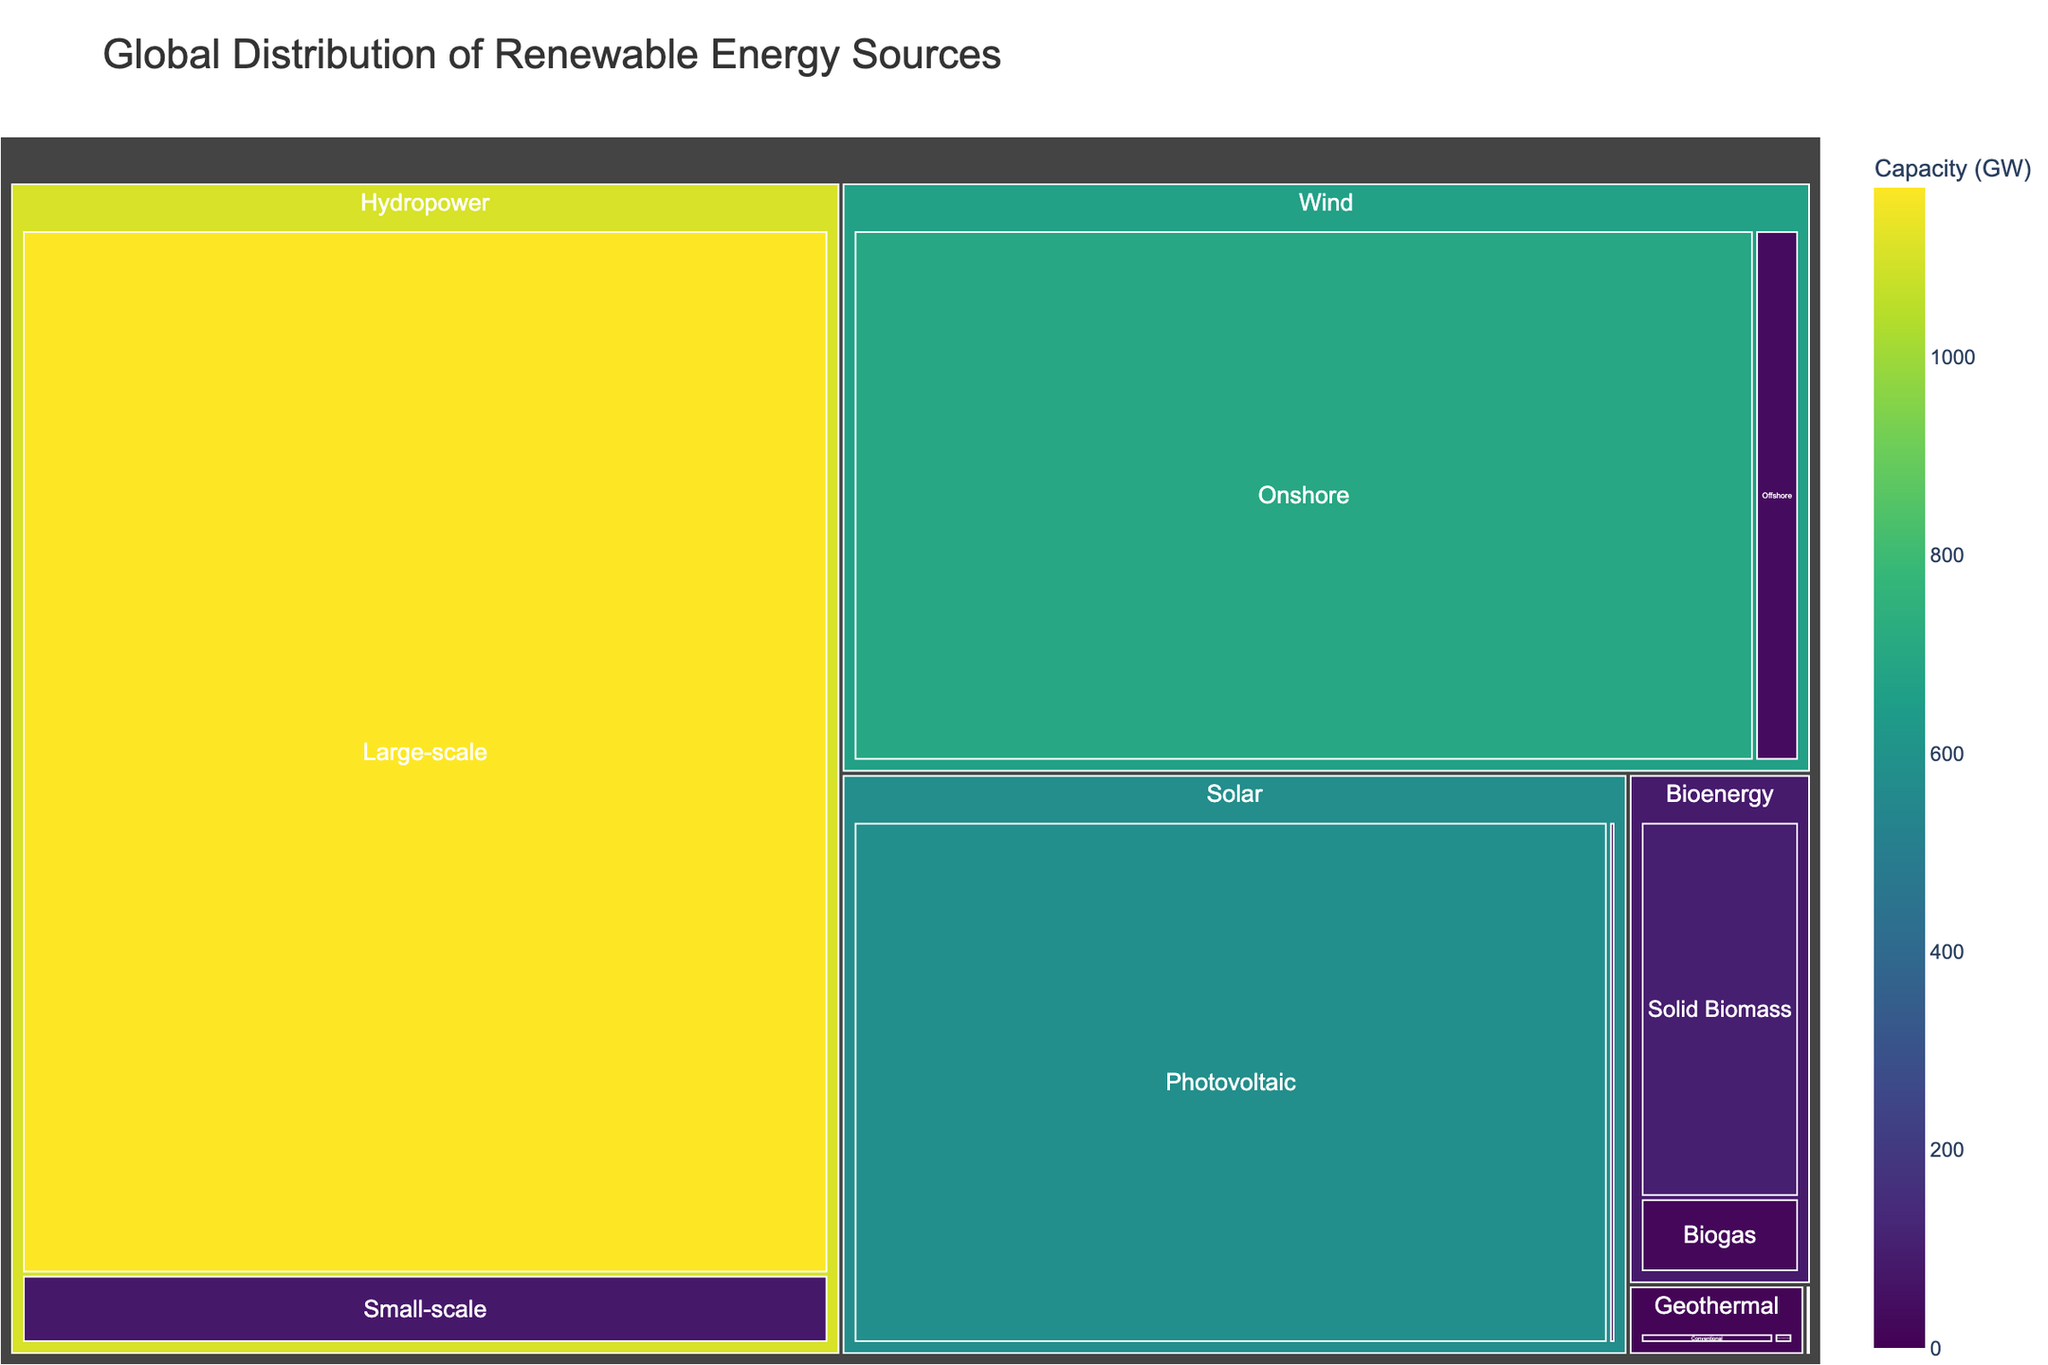What is the title of the treemap? The title is usually displayed at the top of the figure. In this case, it is "Global Distribution of Renewable Energy Sources".
Answer: Global Distribution of Renewable Energy Sources What is the total capacity of solar energy sources? To find the total capacity of solar energy sources, sum the capacities of Photovoltaic and Concentrated Solar Power: 580 GW + 6 GW = 586 GW.
Answer: 586 GW Which type of renewable energy source has the highest capacity? Look for the largest section in the treemap; this corresponds to Hydropower with Large-scale Hydropower having a capacity of 1170 GW.
Answer: Hydropower What is the capacity difference between Offshore Wind and Onshore Wind? Subtract the capacity of Offshore Wind from Onshore Wind: 699 GW - 35 GW = 664 GW.
Answer: 664 GW How many types of solar energy sources are displayed in the treemap? The diagram shows two subdivisions under Solar: Photovoltaic and Concentrated Solar Power.
Answer: 2 Which renewable energy source has the smallest capacity? The smallest section in the treemap is Ocean Power with Wave having a capacity of 0.1 GW.
Answer: Ocean Power, Wave What is the combined capacity of wind energy sources? Sum the capacities of Onshore and Offshore Wind: 699 GW + 35 GW = 734 GW.
Answer: 734 GW Which has a higher capacity, Solid Biomass or Biogas? By how much? Compare the capacities of Solid Biomass and Biogas: Solid Biomass 100 GW is greater than Biogas 20 GW. The difference is 100 GW - 20 GW = 80 GW.
Answer: Solid Biomass, 80 GW What is the smallest capacity among hydropower energy sources, and what source does it belong to? The smaller portion within Hydropower is Small-scale Hydropower with a capacity of 78 GW.
Answer: Small-scale Hydropower, 78 GW How do the capacities of Conventional Geothermal and Enhanced Geothermal Systems compare? Conventional Geothermal (14 GW) is larger than Enhanced Geothermal Systems (2 GW) by 12 GW (14 GW - 2 GW).
Answer: Conventional Geothermal, 12 GW 